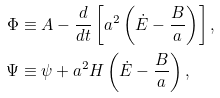<formula> <loc_0><loc_0><loc_500><loc_500>\Phi & \equiv A - \frac { d } { d t } \left [ a ^ { 2 } \left ( \dot { E } - \frac { B } { a } \right ) \right ] , \\ \Psi & \equiv \psi + a ^ { 2 } H \left ( \dot { E } - \frac { B } { a } \right ) ,</formula> 